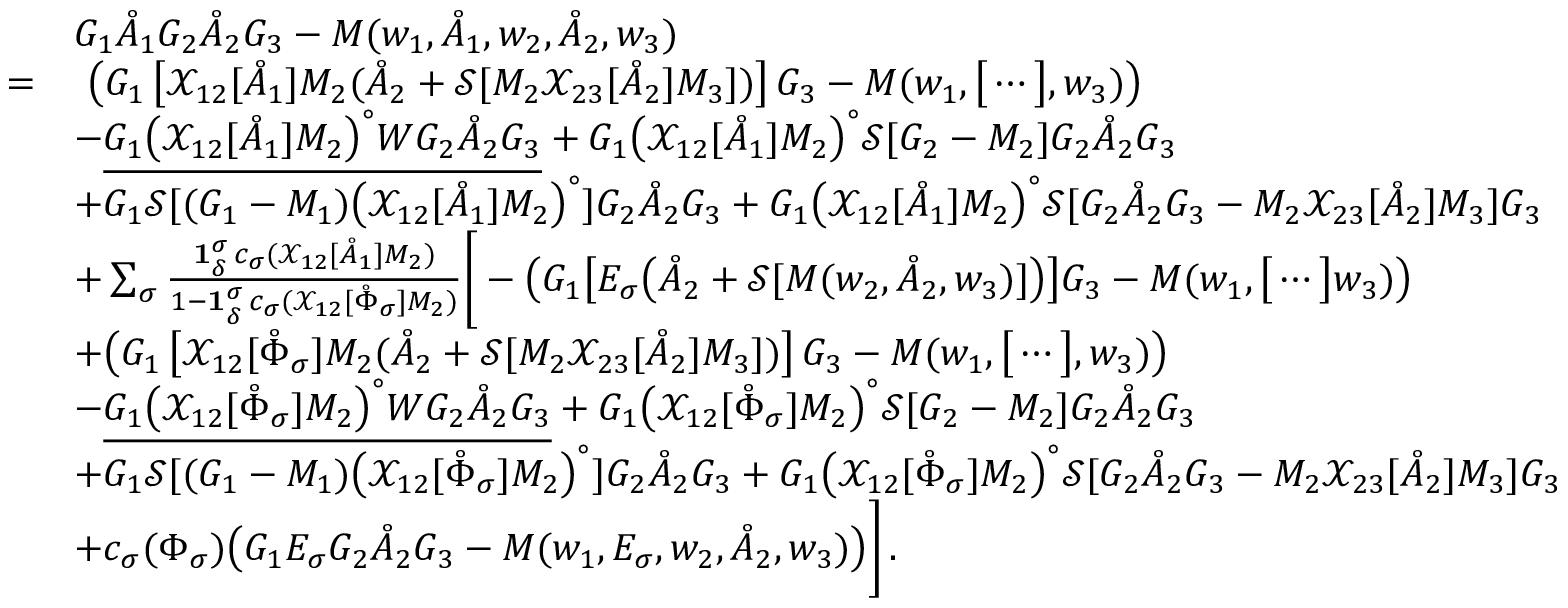Convert formula to latex. <formula><loc_0><loc_0><loc_500><loc_500>\begin{array} { r l } & { G _ { 1 } \mathring { A } _ { 1 } G _ { 2 } \mathring { A } _ { 2 } G _ { 3 } - M ( w _ { 1 } , \mathring { A } _ { 1 } , w _ { 2 } , \mathring { A } _ { 2 } , w _ { 3 } ) } \\ { = } & { \ \left ( G _ { 1 } \, \left [ \mathcal { X } _ { 1 2 } [ \mathring { A } _ { 1 } ] M _ { 2 } ( \mathring { A } _ { 2 } + \mathcal { S } [ M _ { 2 } \mathcal { X } _ { 2 3 } [ \mathring { A } _ { 2 } ] M _ { 3 } ] ) \right ] \, G _ { 3 } - M ( w _ { 1 } , \left [ \cdots \right ] , w _ { 3 } ) \right ) } \\ & { - \underline { { G _ { 1 } \left ( \mathcal { X } _ { 1 2 } [ \mathring { A } _ { 1 } ] M _ { 2 } \right ) ^ { \circ } W G _ { 2 } \mathring { A } _ { 2 } G _ { 3 } } } + G _ { 1 } \left ( \mathcal { X } _ { 1 2 } [ \mathring { A } _ { 1 } ] M _ { 2 } \right ) ^ { \circ } \mathcal { S } [ G _ { 2 } - M _ { 2 } ] G _ { 2 } \mathring { A } _ { 2 } G _ { 3 } } \\ & { + G _ { 1 } \mathcal { S } [ ( G _ { 1 } - M _ { 1 } ) \left ( \mathcal { X } _ { 1 2 } [ \mathring { A } _ { 1 } ] M _ { 2 } \right ) ^ { \circ } ] G _ { 2 } \mathring { A } _ { 2 } G _ { 3 } + G _ { 1 } \left ( \mathcal { X } _ { 1 2 } [ \mathring { A } _ { 1 } ] M _ { 2 } \right ) ^ { \circ } \mathcal { S } [ G _ { 2 } \mathring { A } _ { 2 } G _ { 3 } - M _ { 2 } \mathcal { X } _ { 2 3 } [ \mathring { A } _ { 2 } ] M _ { 3 } ] G _ { 3 } } \\ & { + \sum _ { \sigma } \frac { 1 _ { \delta } ^ { \sigma } \, c _ { \sigma } ( \mathcal { X } _ { 1 2 } [ \mathring { A } _ { 1 } ] M _ { 2 } ) } { 1 - 1 _ { \delta } ^ { \sigma } \, c _ { \sigma } ( \mathcal { X } _ { 1 2 } [ \mathring { \Phi } _ { \sigma } ] M _ { 2 } ) } \left [ - \left ( G _ { 1 } \left [ E _ { \sigma } \left ( \mathring { A } _ { 2 } + \mathcal { S } [ M ( w _ { 2 } , \mathring { A } _ { 2 } , w _ { 3 } ) ] \right ) \right ] G _ { 3 } - M ( w _ { 1 } , \left [ \cdots \right ] w _ { 3 } ) \right ) } \\ & { + \left ( G _ { 1 } \, \left [ \mathcal { X } _ { 1 2 } [ \mathring { \Phi } _ { \sigma } ] M _ { 2 } ( \mathring { A } _ { 2 } + \mathcal { S } [ M _ { 2 } \mathcal { X } _ { 2 3 } [ \mathring { A } _ { 2 } ] M _ { 3 } ] ) \right ] \, G _ { 3 } - M ( w _ { 1 } , \left [ \cdots \right ] , w _ { 3 } ) \right ) } \\ & { - \underline { { G _ { 1 } \left ( \mathcal { X } _ { 1 2 } [ \mathring { \Phi } _ { \sigma } ] M _ { 2 } \right ) ^ { \circ } W G _ { 2 } \mathring { A } _ { 2 } G _ { 3 } } } + G _ { 1 } \left ( \mathcal { X } _ { 1 2 } [ \mathring { \Phi } _ { \sigma } ] M _ { 2 } \right ) ^ { \circ } \mathcal { S } [ G _ { 2 } - M _ { 2 } ] G _ { 2 } \mathring { A } _ { 2 } G _ { 3 } } \\ & { + G _ { 1 } \mathcal { S } [ ( G _ { 1 } - M _ { 1 } ) \left ( \mathcal { X } _ { 1 2 } [ \mathring { \Phi } _ { \sigma } ] M _ { 2 } \right ) ^ { \circ } ] G _ { 2 } \mathring { A } _ { 2 } G _ { 3 } + G _ { 1 } \left ( \mathcal { X } _ { 1 2 } [ \mathring { \Phi } _ { \sigma } ] M _ { 2 } \right ) ^ { \circ } \mathcal { S } [ G _ { 2 } \mathring { A } _ { 2 } G _ { 3 } - M _ { 2 } \mathcal { X } _ { 2 3 } [ \mathring { A } _ { 2 } ] M _ { 3 } ] G _ { 3 } } \\ & { + c _ { \sigma } ( \Phi _ { \sigma } ) \left ( G _ { 1 } E _ { \sigma } G _ { 2 } \mathring { A } _ { 2 } G _ { 3 } - M ( w _ { 1 } , E _ { \sigma } , w _ { 2 } , \mathring { A } _ { 2 } , w _ { 3 } ) \right ) \right ] \, . } \end{array}</formula> 